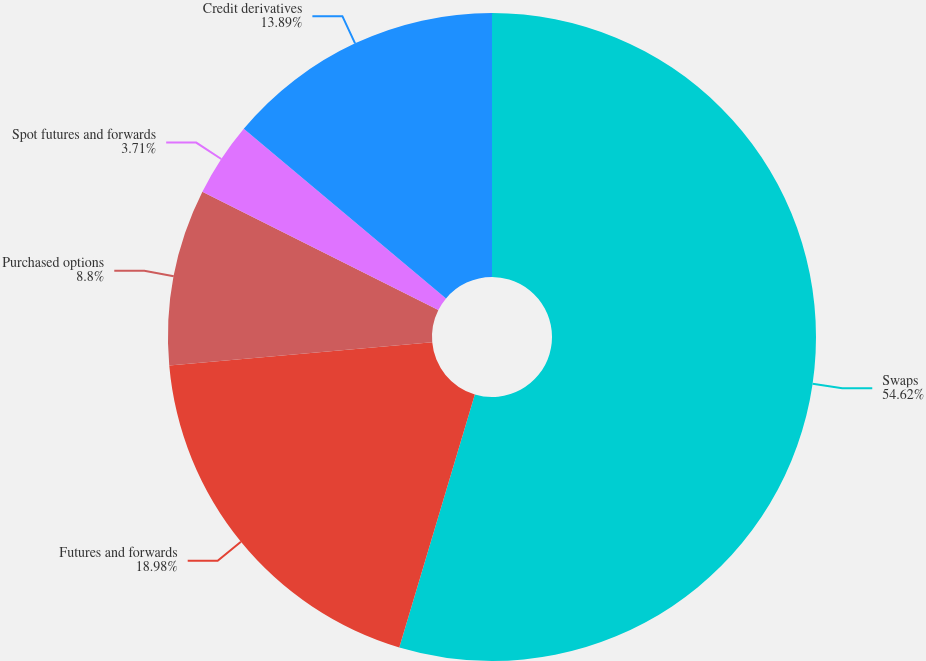Convert chart to OTSL. <chart><loc_0><loc_0><loc_500><loc_500><pie_chart><fcel>Swaps<fcel>Futures and forwards<fcel>Purchased options<fcel>Spot futures and forwards<fcel>Credit derivatives<nl><fcel>54.62%<fcel>18.98%<fcel>8.8%<fcel>3.71%<fcel>13.89%<nl></chart> 